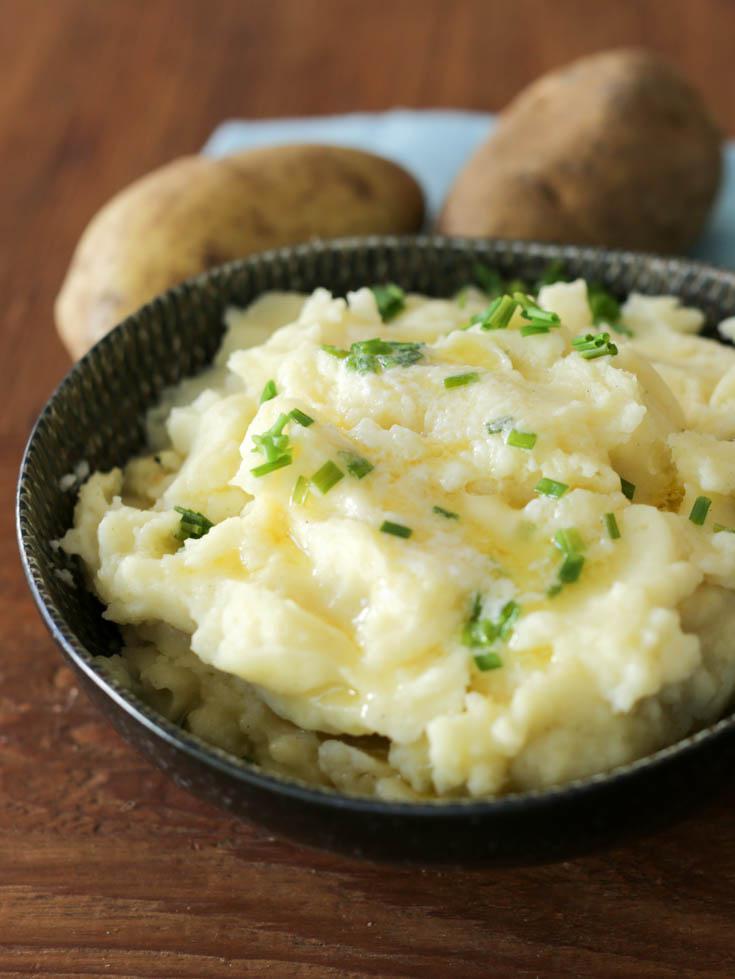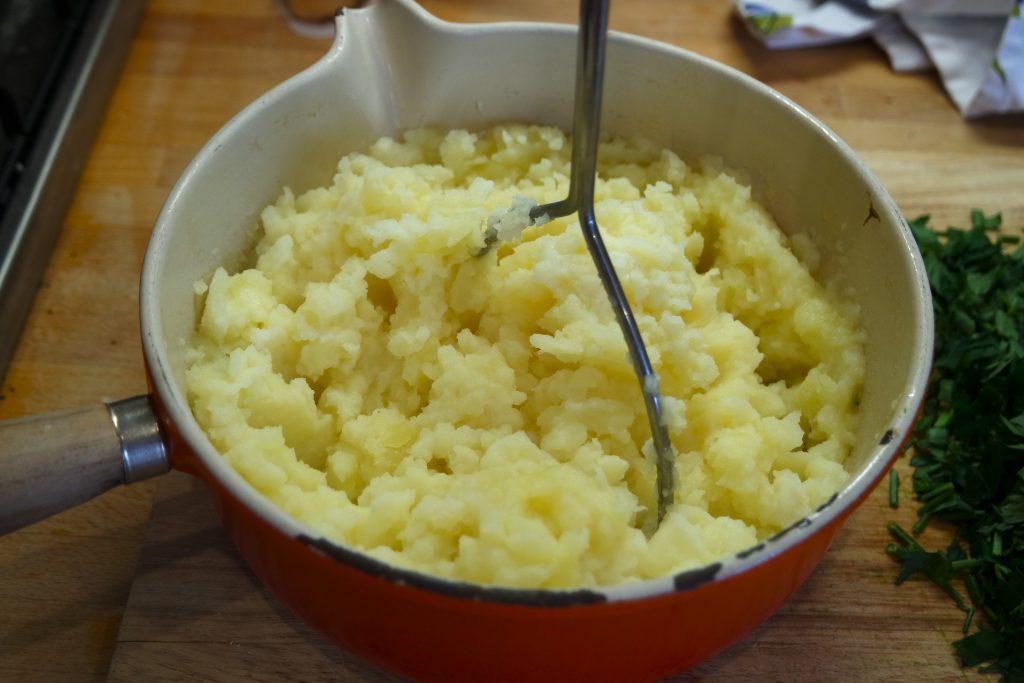The first image is the image on the left, the second image is the image on the right. Assess this claim about the two images: "Mashed potatoes in a black bowl with a ridge design are topped with melted butter and small pieces of chive.". Correct or not? Answer yes or no. Yes. The first image is the image on the left, the second image is the image on the right. For the images shown, is this caption "There are green flakes garnishing only one of the dishes." true? Answer yes or no. Yes. 